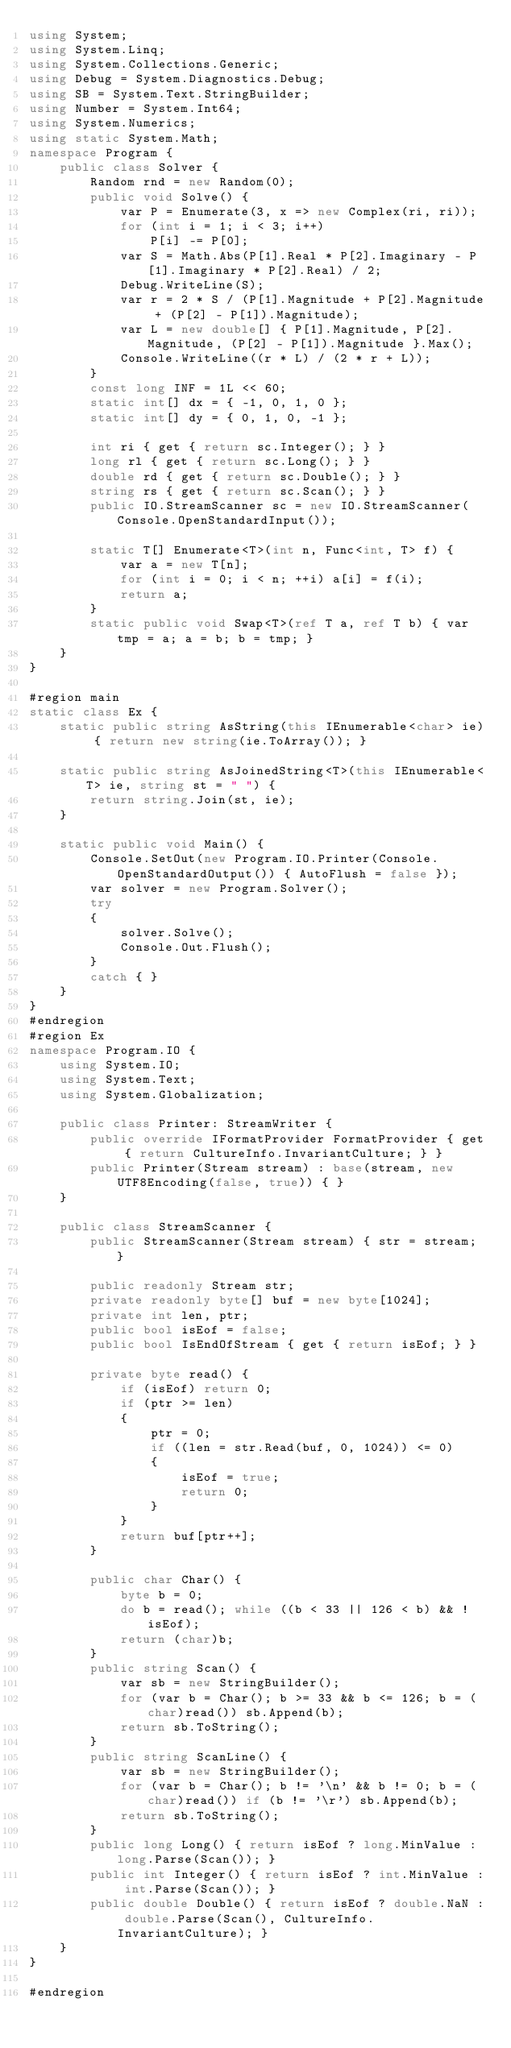<code> <loc_0><loc_0><loc_500><loc_500><_C#_>using System;
using System.Linq;
using System.Collections.Generic;
using Debug = System.Diagnostics.Debug;
using SB = System.Text.StringBuilder;
using Number = System.Int64;
using System.Numerics;
using static System.Math;
namespace Program {
    public class Solver {
        Random rnd = new Random(0);
        public void Solve() {
            var P = Enumerate(3, x => new Complex(ri, ri));
            for (int i = 1; i < 3; i++)
                P[i] -= P[0];
            var S = Math.Abs(P[1].Real * P[2].Imaginary - P[1].Imaginary * P[2].Real) / 2;
            Debug.WriteLine(S);
            var r = 2 * S / (P[1].Magnitude + P[2].Magnitude + (P[2] - P[1]).Magnitude);
            var L = new double[] { P[1].Magnitude, P[2].Magnitude, (P[2] - P[1]).Magnitude }.Max();
            Console.WriteLine((r * L) / (2 * r + L));
        }
        const long INF = 1L << 60;
        static int[] dx = { -1, 0, 1, 0 };
        static int[] dy = { 0, 1, 0, -1 };

        int ri { get { return sc.Integer(); } }
        long rl { get { return sc.Long(); } }
        double rd { get { return sc.Double(); } }
        string rs { get { return sc.Scan(); } }
        public IO.StreamScanner sc = new IO.StreamScanner(Console.OpenStandardInput());

        static T[] Enumerate<T>(int n, Func<int, T> f) {
            var a = new T[n];
            for (int i = 0; i < n; ++i) a[i] = f(i);
            return a;
        }
        static public void Swap<T>(ref T a, ref T b) { var tmp = a; a = b; b = tmp; }
    }
}

#region main
static class Ex {
    static public string AsString(this IEnumerable<char> ie) { return new string(ie.ToArray()); }

    static public string AsJoinedString<T>(this IEnumerable<T> ie, string st = " ") {
        return string.Join(st, ie);
    }

    static public void Main() {
        Console.SetOut(new Program.IO.Printer(Console.OpenStandardOutput()) { AutoFlush = false });
        var solver = new Program.Solver();
        try
        {
            solver.Solve();
            Console.Out.Flush();
        }
        catch { }
    }
}
#endregion
#region Ex
namespace Program.IO {
    using System.IO;
    using System.Text;
    using System.Globalization;

    public class Printer: StreamWriter {
        public override IFormatProvider FormatProvider { get { return CultureInfo.InvariantCulture; } }
        public Printer(Stream stream) : base(stream, new UTF8Encoding(false, true)) { }
    }

    public class StreamScanner {
        public StreamScanner(Stream stream) { str = stream; }

        public readonly Stream str;
        private readonly byte[] buf = new byte[1024];
        private int len, ptr;
        public bool isEof = false;
        public bool IsEndOfStream { get { return isEof; } }

        private byte read() {
            if (isEof) return 0;
            if (ptr >= len)
            {
                ptr = 0;
                if ((len = str.Read(buf, 0, 1024)) <= 0)
                {
                    isEof = true;
                    return 0;
                }
            }
            return buf[ptr++];
        }

        public char Char() {
            byte b = 0;
            do b = read(); while ((b < 33 || 126 < b) && !isEof);
            return (char)b;
        }
        public string Scan() {
            var sb = new StringBuilder();
            for (var b = Char(); b >= 33 && b <= 126; b = (char)read()) sb.Append(b);
            return sb.ToString();
        }
        public string ScanLine() {
            var sb = new StringBuilder();
            for (var b = Char(); b != '\n' && b != 0; b = (char)read()) if (b != '\r') sb.Append(b);
            return sb.ToString();
        }
        public long Long() { return isEof ? long.MinValue : long.Parse(Scan()); }
        public int Integer() { return isEof ? int.MinValue : int.Parse(Scan()); }
        public double Double() { return isEof ? double.NaN : double.Parse(Scan(), CultureInfo.InvariantCulture); }
    }
}

#endregion
</code> 